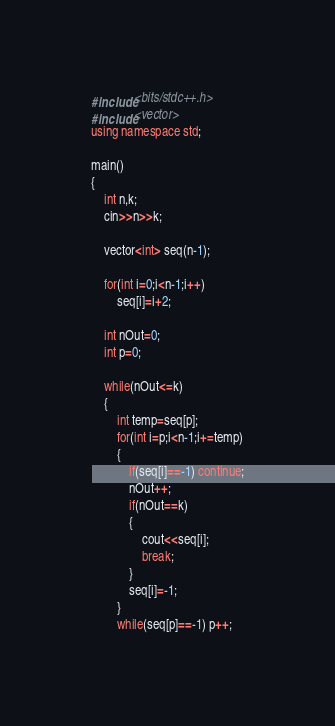<code> <loc_0><loc_0><loc_500><loc_500><_C++_>#include<bits/stdc++.h>
#include<vector>
using namespace std;

main()
{
	int n,k;
	cin>>n>>k;
	
	vector<int> seq(n-1);
		
	for(int i=0;i<n-1;i++)
		seq[i]=i+2;
	
	int nOut=0;
	int p=0;
	
	while(nOut<=k)
	{
		int temp=seq[p];
		for(int i=p;i<n-1;i+=temp)
		{
			if(seq[i]==-1) continue;
			nOut++;
			if(nOut==k) 
			{
				cout<<seq[i];	
				break;
			}
			seq[i]=-1;	
		}
		while(seq[p]==-1) p++;</code> 